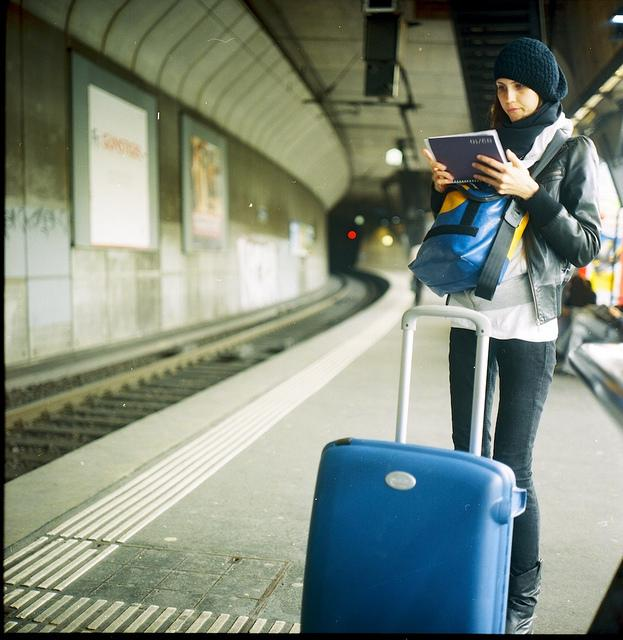What is the best luggage brand in the world?

Choices:
A) rimowa
B) samsonite
C) delsey
D) away away 